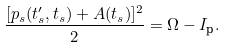<formula> <loc_0><loc_0><loc_500><loc_500>\frac { [ p _ { s } ( t ^ { \prime } _ { s } , t _ { s } ) + A ( t _ { s } ) ] ^ { 2 } } { 2 } = \Omega - I _ { \text  p}.</formula> 